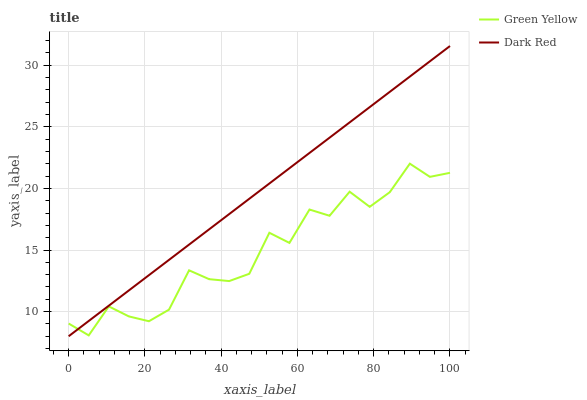Does Green Yellow have the minimum area under the curve?
Answer yes or no. Yes. Does Dark Red have the maximum area under the curve?
Answer yes or no. Yes. Does Green Yellow have the maximum area under the curve?
Answer yes or no. No. Is Dark Red the smoothest?
Answer yes or no. Yes. Is Green Yellow the roughest?
Answer yes or no. Yes. Is Green Yellow the smoothest?
Answer yes or no. No. Does Dark Red have the lowest value?
Answer yes or no. Yes. Does Green Yellow have the lowest value?
Answer yes or no. No. Does Dark Red have the highest value?
Answer yes or no. Yes. Does Green Yellow have the highest value?
Answer yes or no. No. Does Dark Red intersect Green Yellow?
Answer yes or no. Yes. Is Dark Red less than Green Yellow?
Answer yes or no. No. Is Dark Red greater than Green Yellow?
Answer yes or no. No. 